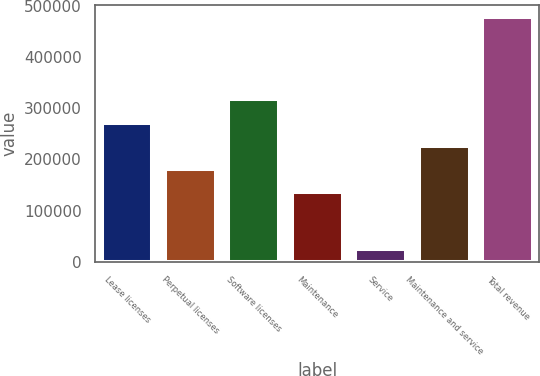Convert chart. <chart><loc_0><loc_0><loc_500><loc_500><bar_chart><fcel>Lease licenses<fcel>Perpetual licenses<fcel>Software licenses<fcel>Maintenance<fcel>Service<fcel>Maintenance and service<fcel>Total revenue<nl><fcel>271951<fcel>181166<fcel>318154<fcel>135773<fcel>24412<fcel>226558<fcel>478339<nl></chart> 